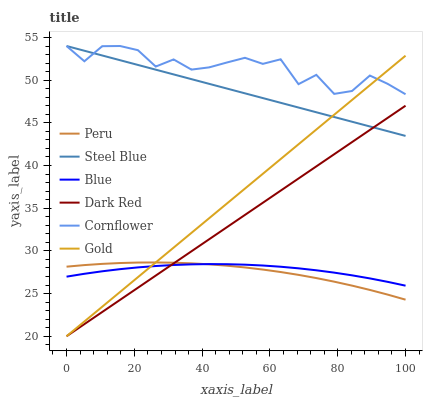Does Peru have the minimum area under the curve?
Answer yes or no. Yes. Does Cornflower have the maximum area under the curve?
Answer yes or no. Yes. Does Gold have the minimum area under the curve?
Answer yes or no. No. Does Gold have the maximum area under the curve?
Answer yes or no. No. Is Dark Red the smoothest?
Answer yes or no. Yes. Is Cornflower the roughest?
Answer yes or no. Yes. Is Gold the smoothest?
Answer yes or no. No. Is Gold the roughest?
Answer yes or no. No. Does Gold have the lowest value?
Answer yes or no. Yes. Does Cornflower have the lowest value?
Answer yes or no. No. Does Steel Blue have the highest value?
Answer yes or no. Yes. Does Gold have the highest value?
Answer yes or no. No. Is Blue less than Cornflower?
Answer yes or no. Yes. Is Cornflower greater than Peru?
Answer yes or no. Yes. Does Cornflower intersect Gold?
Answer yes or no. Yes. Is Cornflower less than Gold?
Answer yes or no. No. Is Cornflower greater than Gold?
Answer yes or no. No. Does Blue intersect Cornflower?
Answer yes or no. No. 